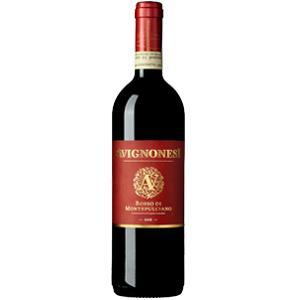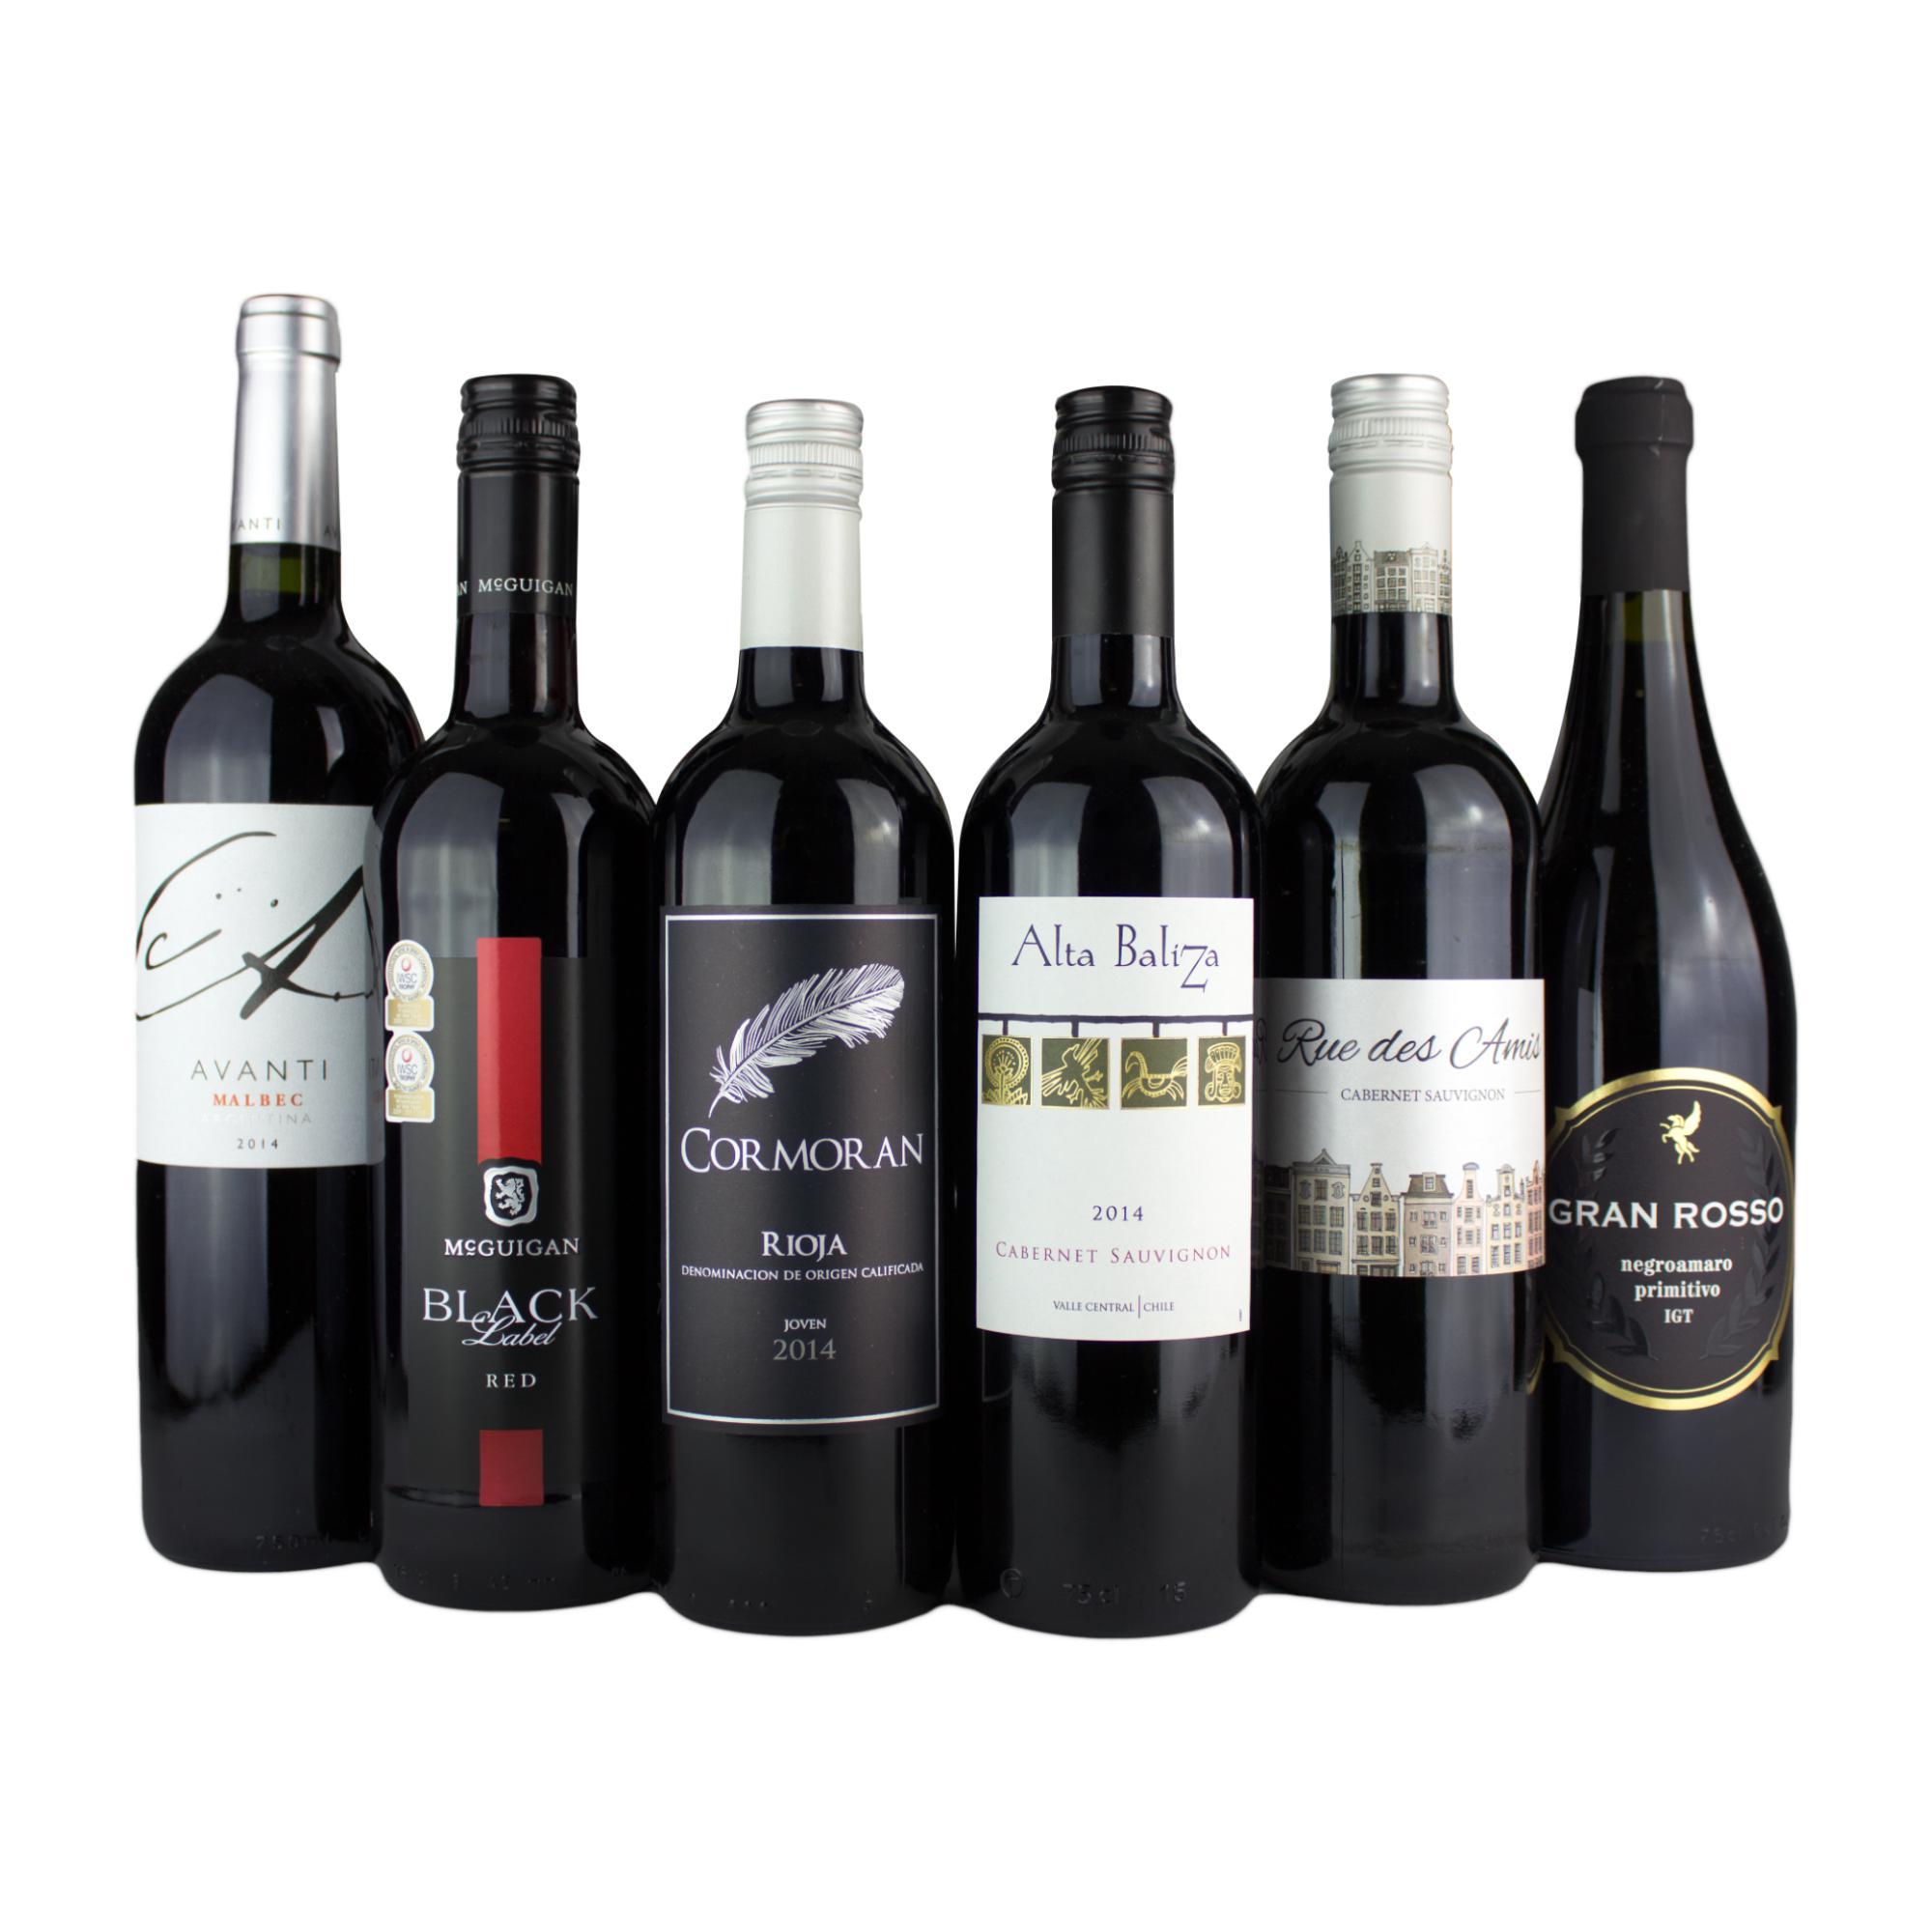The first image is the image on the left, the second image is the image on the right. Examine the images to the left and right. Is the description "A large variety of wines is paired with a single bottle with colored top." accurate? Answer yes or no. Yes. 